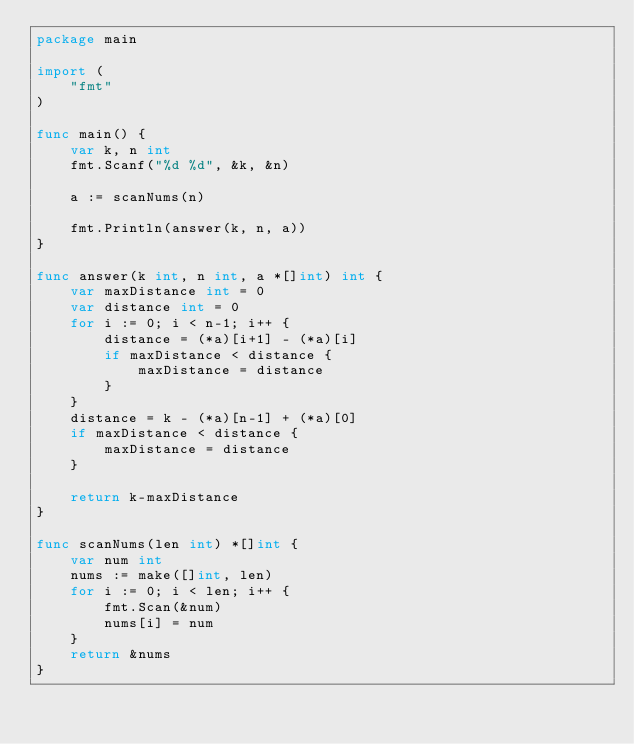<code> <loc_0><loc_0><loc_500><loc_500><_Go_>package main

import (
	"fmt"
)

func main() {
	var k, n int
	fmt.Scanf("%d %d", &k, &n)

	a := scanNums(n)

	fmt.Println(answer(k, n, a))
}

func answer(k int, n int, a *[]int) int {
	var maxDistance int = 0
	var distance int = 0
	for i := 0; i < n-1; i++ {
		distance = (*a)[i+1] - (*a)[i]
		if maxDistance < distance {
			maxDistance = distance
		}
	}
	distance = k - (*a)[n-1] + (*a)[0]
	if maxDistance < distance {
		maxDistance = distance
	}

	return k-maxDistance
}

func scanNums(len int) *[]int {
	var num int
	nums := make([]int, len)
	for i := 0; i < len; i++ {
		fmt.Scan(&num)
		nums[i] = num
	}
	return &nums
}</code> 